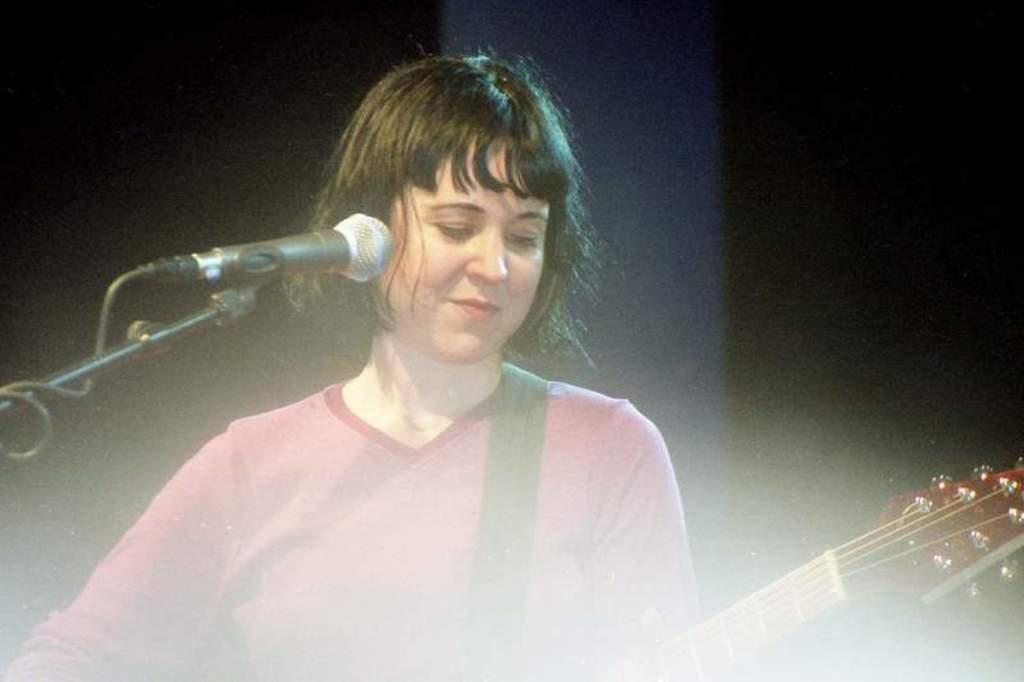Who is the main subject in the image? There is a girl in the image. What is the girl doing in the image? The girl is standing and holding a guitar in her hand. Can you describe the girl's appearance? The girl has short hair. What other objects can be seen in the image? There is a microphone on the left side of the image. What type of ocean can be seen in the background of the image? There is no ocean present in the image; it features a girl holding a guitar and a microphone. What invention is the girl using to play the guitar in the image? The girl is not using any invention to play the guitar in the image; she is simply holding it in her hand. 